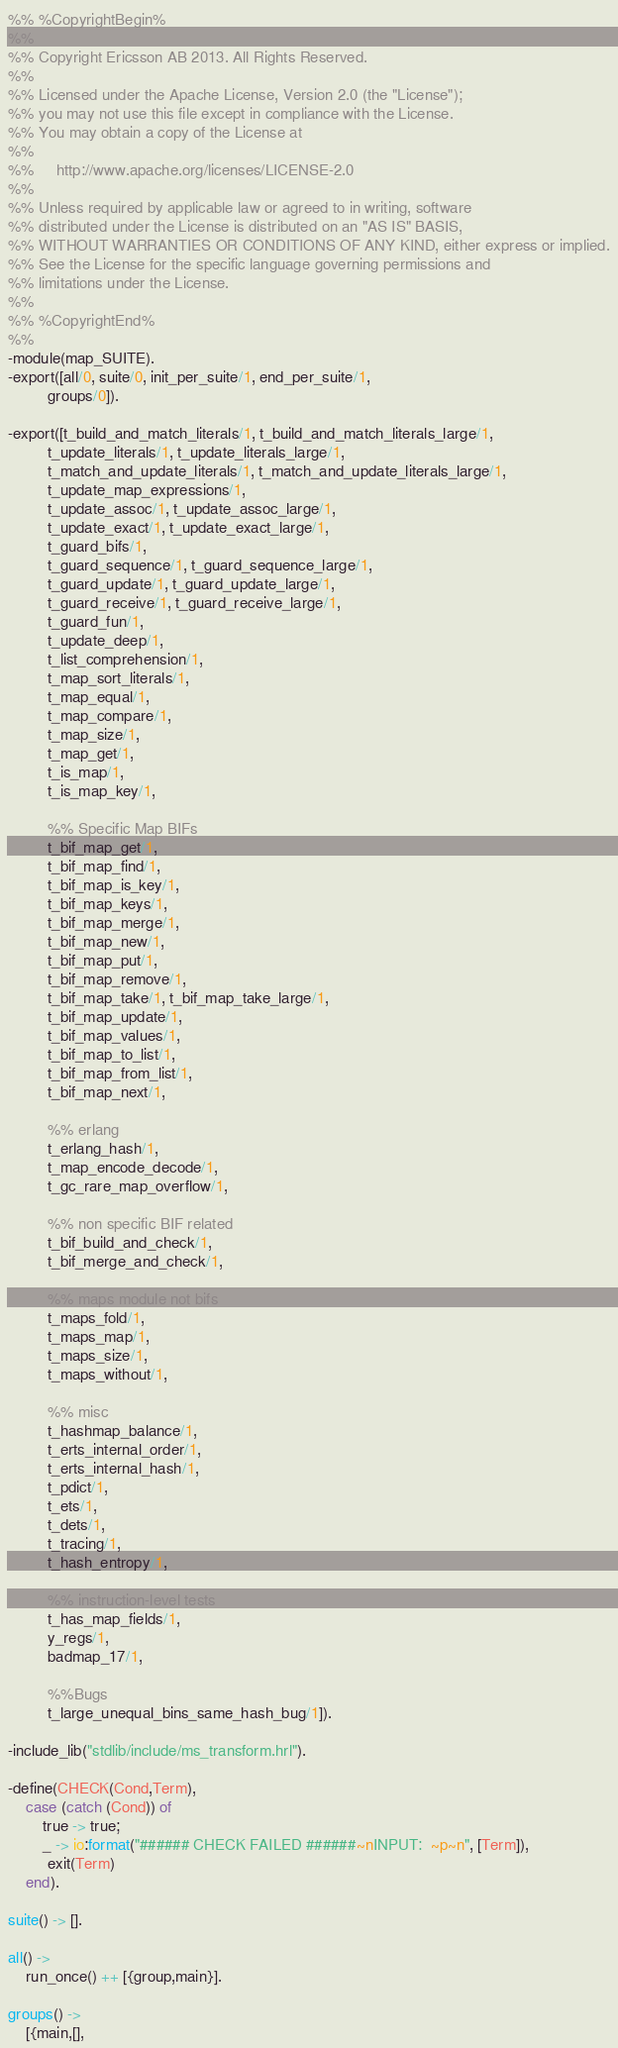<code> <loc_0><loc_0><loc_500><loc_500><_Erlang_>%% %CopyrightBegin%
%% 
%% Copyright Ericsson AB 2013. All Rights Reserved.
%% 
%% Licensed under the Apache License, Version 2.0 (the "License");
%% you may not use this file except in compliance with the License.
%% You may obtain a copy of the License at
%%
%%     http://www.apache.org/licenses/LICENSE-2.0
%%
%% Unless required by applicable law or agreed to in writing, software
%% distributed under the License is distributed on an "AS IS" BASIS,
%% WITHOUT WARRANTIES OR CONDITIONS OF ANY KIND, either express or implied.
%% See the License for the specific language governing permissions and
%% limitations under the License.
%% 
%% %CopyrightEnd%
%%
-module(map_SUITE).
-export([all/0, suite/0, init_per_suite/1, end_per_suite/1,
         groups/0]).

-export([t_build_and_match_literals/1, t_build_and_match_literals_large/1,
         t_update_literals/1, t_update_literals_large/1,
         t_match_and_update_literals/1, t_match_and_update_literals_large/1,
         t_update_map_expressions/1,
         t_update_assoc/1, t_update_assoc_large/1,
         t_update_exact/1, t_update_exact_large/1,
         t_guard_bifs/1,
         t_guard_sequence/1, t_guard_sequence_large/1,
         t_guard_update/1, t_guard_update_large/1,
         t_guard_receive/1, t_guard_receive_large/1,
         t_guard_fun/1,
         t_update_deep/1,
         t_list_comprehension/1,
         t_map_sort_literals/1,
         t_map_equal/1,
         t_map_compare/1,
         t_map_size/1,
         t_map_get/1,
         t_is_map/1,
         t_is_map_key/1,

         %% Specific Map BIFs
         t_bif_map_get/1,
         t_bif_map_find/1,
         t_bif_map_is_key/1,
         t_bif_map_keys/1,
         t_bif_map_merge/1,
         t_bif_map_new/1,
         t_bif_map_put/1,
         t_bif_map_remove/1,
         t_bif_map_take/1, t_bif_map_take_large/1,
         t_bif_map_update/1,
         t_bif_map_values/1,
         t_bif_map_to_list/1,
         t_bif_map_from_list/1,
         t_bif_map_next/1,

         %% erlang
         t_erlang_hash/1,
         t_map_encode_decode/1,
         t_gc_rare_map_overflow/1,

         %% non specific BIF related
         t_bif_build_and_check/1,
         t_bif_merge_and_check/1,

         %% maps module not bifs
         t_maps_fold/1,
         t_maps_map/1,
         t_maps_size/1,
         t_maps_without/1,

         %% misc
         t_hashmap_balance/1,
         t_erts_internal_order/1,
         t_erts_internal_hash/1,
         t_pdict/1,
         t_ets/1,
         t_dets/1,
         t_tracing/1,
         t_hash_entropy/1,

         %% instruction-level tests
         t_has_map_fields/1,
         y_regs/1,
         badmap_17/1,

         %%Bugs
         t_large_unequal_bins_same_hash_bug/1]).

-include_lib("stdlib/include/ms_transform.hrl").

-define(CHECK(Cond,Term),
	case (catch (Cond)) of
	    true -> true;
	    _ -> io:format("###### CHECK FAILED ######~nINPUT:  ~p~n", [Term]),
		 exit(Term)
	end).

suite() -> [].

all() ->
    run_once() ++ [{group,main}].

groups() ->
    [{main,[],</code> 